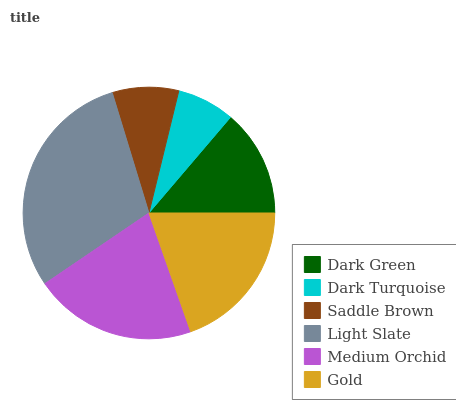Is Dark Turquoise the minimum?
Answer yes or no. Yes. Is Light Slate the maximum?
Answer yes or no. Yes. Is Saddle Brown the minimum?
Answer yes or no. No. Is Saddle Brown the maximum?
Answer yes or no. No. Is Saddle Brown greater than Dark Turquoise?
Answer yes or no. Yes. Is Dark Turquoise less than Saddle Brown?
Answer yes or no. Yes. Is Dark Turquoise greater than Saddle Brown?
Answer yes or no. No. Is Saddle Brown less than Dark Turquoise?
Answer yes or no. No. Is Gold the high median?
Answer yes or no. Yes. Is Dark Green the low median?
Answer yes or no. Yes. Is Medium Orchid the high median?
Answer yes or no. No. Is Gold the low median?
Answer yes or no. No. 